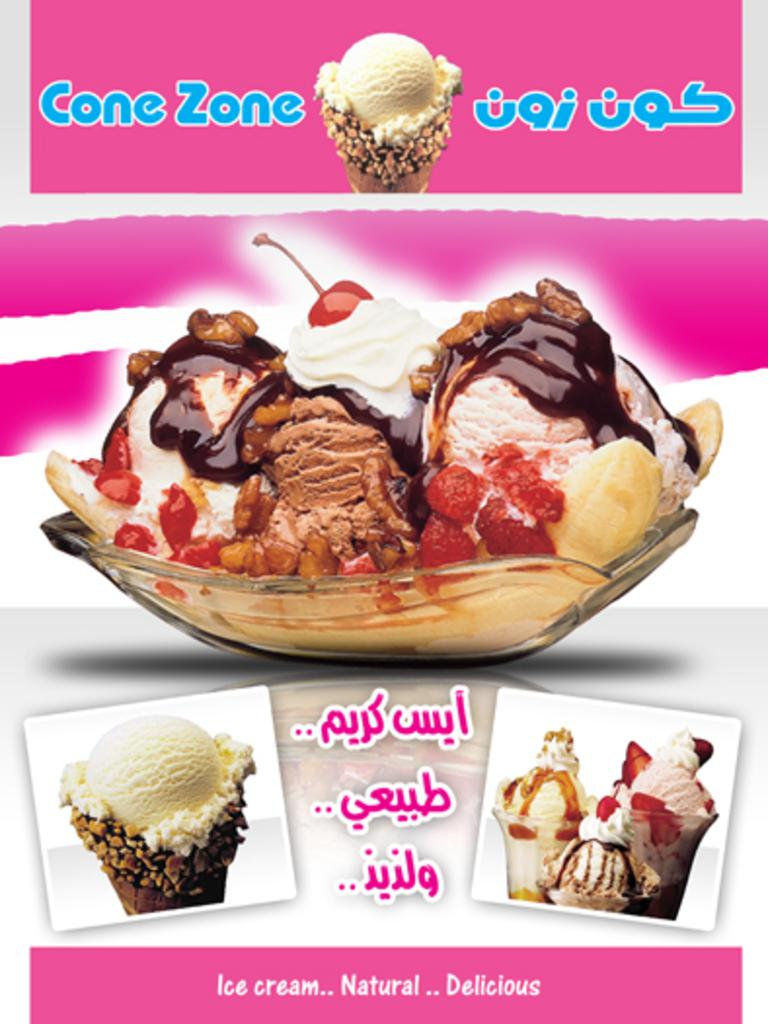What is the main subject of the image? The main subject of the image is an advertisement poster. What is depicted on the poster? There is an ice cream in a glass bowl on the poster. Are there any words on the poster? Yes, there is text on the poster. What type of chain can be seen connecting the ice cream to the poster? There is no chain present in the image; the ice cream is depicted on the poster, not physically connected to it. 